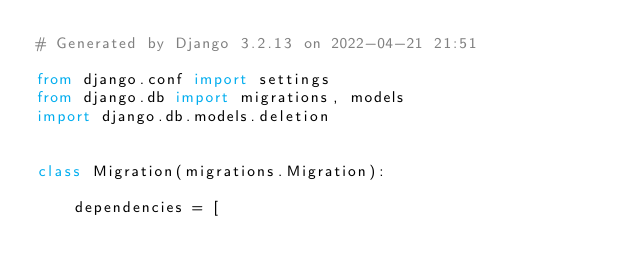<code> <loc_0><loc_0><loc_500><loc_500><_Python_># Generated by Django 3.2.13 on 2022-04-21 21:51

from django.conf import settings
from django.db import migrations, models
import django.db.models.deletion


class Migration(migrations.Migration):

    dependencies = [</code> 